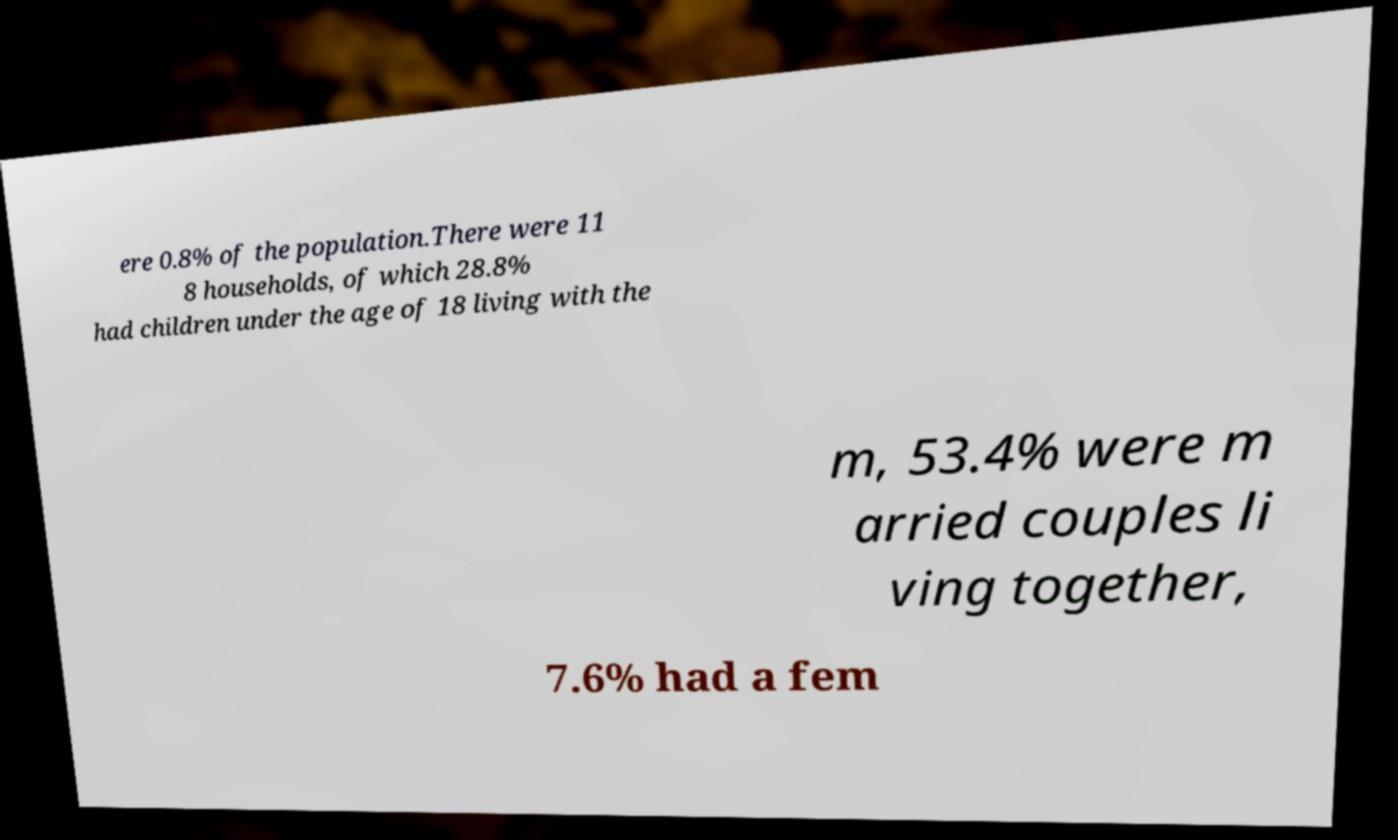Please read and relay the text visible in this image. What does it say? ere 0.8% of the population.There were 11 8 households, of which 28.8% had children under the age of 18 living with the m, 53.4% were m arried couples li ving together, 7.6% had a fem 